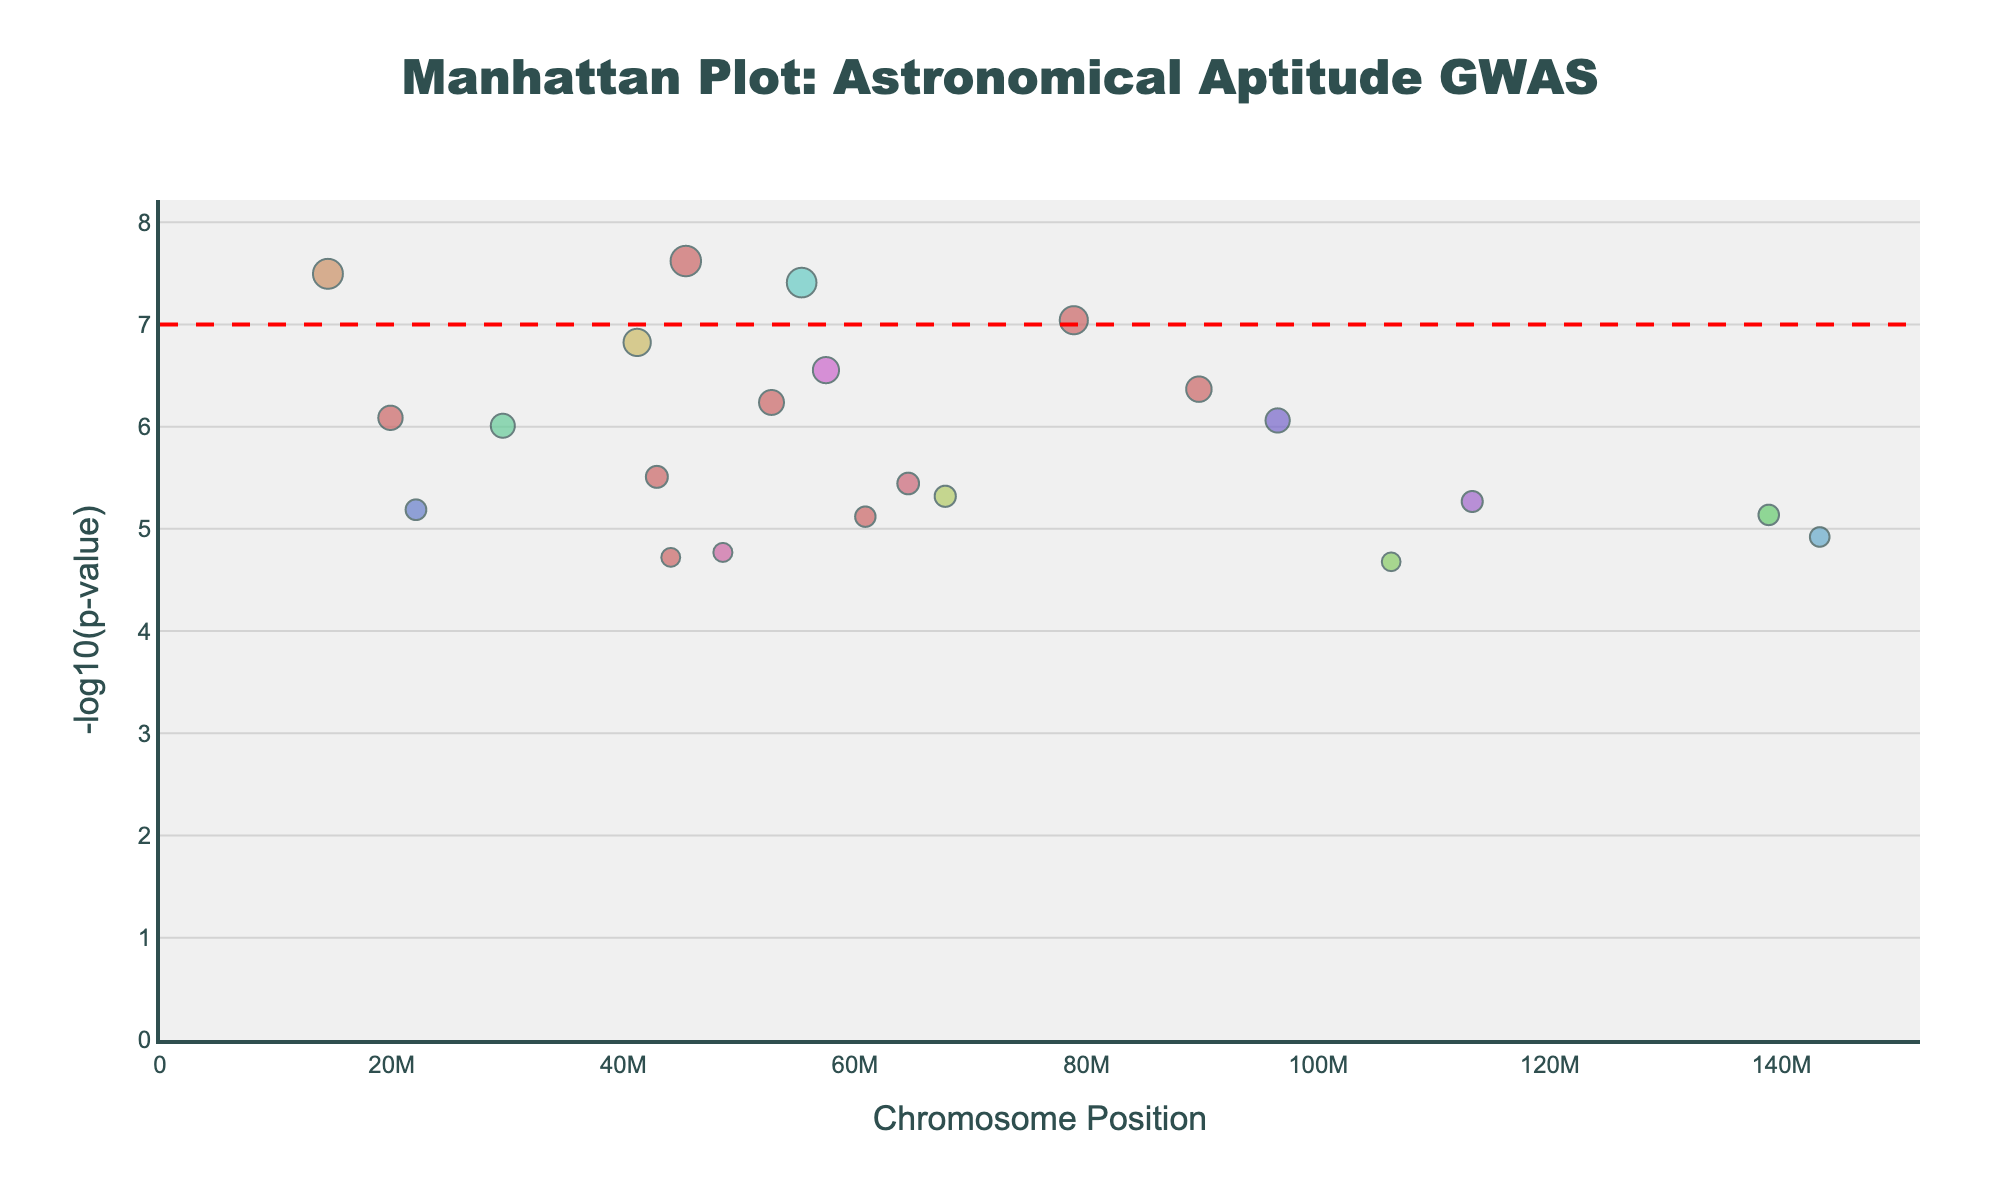What is the title of the plot? The title can be found typically at the top of the figure. In this Manhattan plot, it is "Manhattan Plot: Astronomical Aptitude GWAS".
Answer: Manhattan Plot: Astronomical Aptitude GWAS What do the axes represent? The x-axis represents the chromosome positions, indicating the location of SNPs on different chromosomes, while the y-axis represents the -log10(p-value) of the association between each SNP and astronomical aptitude.
Answer: Chromosome Position and -log10(p-value) What does the red dashed line on the plot indicate? The red dashed line represents the threshold for genome-wide significance. It indicates the point below which the p-values are considered statistically significant.
Answer: Threshold for genome-wide significance Which chromosome has the SNP with the smallest p-value? Identify the point with the highest y-value (i.e., tallest peak) on the plot. The chromosome and specific SNP can be traced from the x-axis position and hover information.
Answer: Chromosome 1 (SNP rs2070744) What is the highest -log10(p-value) observed in the plot, and which SNP corresponds to it? Find the highest peak on the y-axis. The -log10(p-value) for this SNP can be directly read from the y-axis, and the corresponding SNP is typically revealed upon hovering over the data point.
Answer: About 7.5, SNP rs2070744 How many chromosomes have more than one significant SNP based on p-value less than 1e-6? Scan through the plot and count how many chromosomes show more than one distinct peak above this threshold.
Answer: Chromosome 1, 6, and 22 Between chromosomes 15 and 20, which one has a smaller significant p-value? Compare the highest peaks (tallest points) on chromosomes 15 and 20. Check their -log10(p-values) to see which is higher (implying a smaller p-value).
Answer: Chromosome 15 What is the range of chromosome positions depicted on the x-axis? The range can be determined by looking at the minimum and maximum values on the x-axis, covering the position of SNPs across chromosomes.
Answer: Approximately from 0 to 150 million base pairs How many SNPs have a -log10(p-value) greater than 6? Count the number of data points (peaks) that lie above the y=6 line (equivalent to a p-value of 1e-6).
Answer: 14 Which SNP has the largest marker size, and what does this represent? The largest marker size indicates the SNP with the smallest p-value, as marker size is proportional to -log10(p-value). Identify the largest point on the plot for this information.
Answer: SNP rs2070744, representing the smallest p-value 